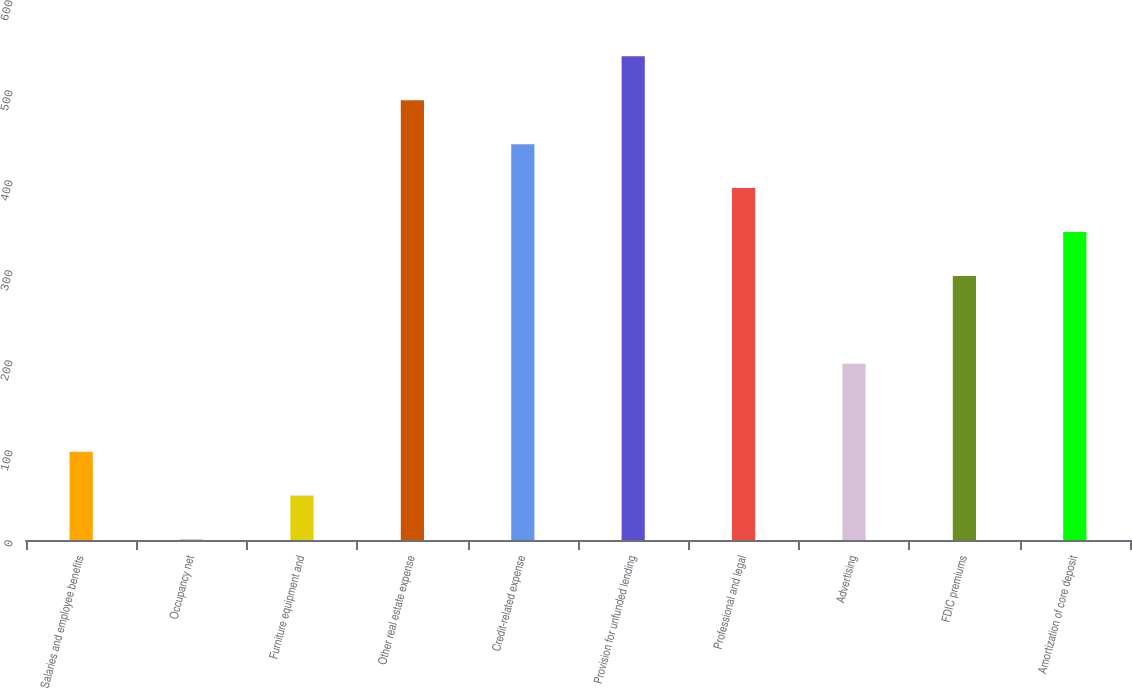Convert chart. <chart><loc_0><loc_0><loc_500><loc_500><bar_chart><fcel>Salaries and employee benefits<fcel>Occupancy net<fcel>Furniture equipment and<fcel>Other real estate expense<fcel>Credit-related expense<fcel>Provision for unfunded lending<fcel>Professional and legal<fcel>Advertising<fcel>FDIC premiums<fcel>Amortization of core deposit<nl><fcel>98.12<fcel>0.5<fcel>49.31<fcel>488.6<fcel>439.79<fcel>537.41<fcel>390.98<fcel>195.74<fcel>293.36<fcel>342.17<nl></chart> 